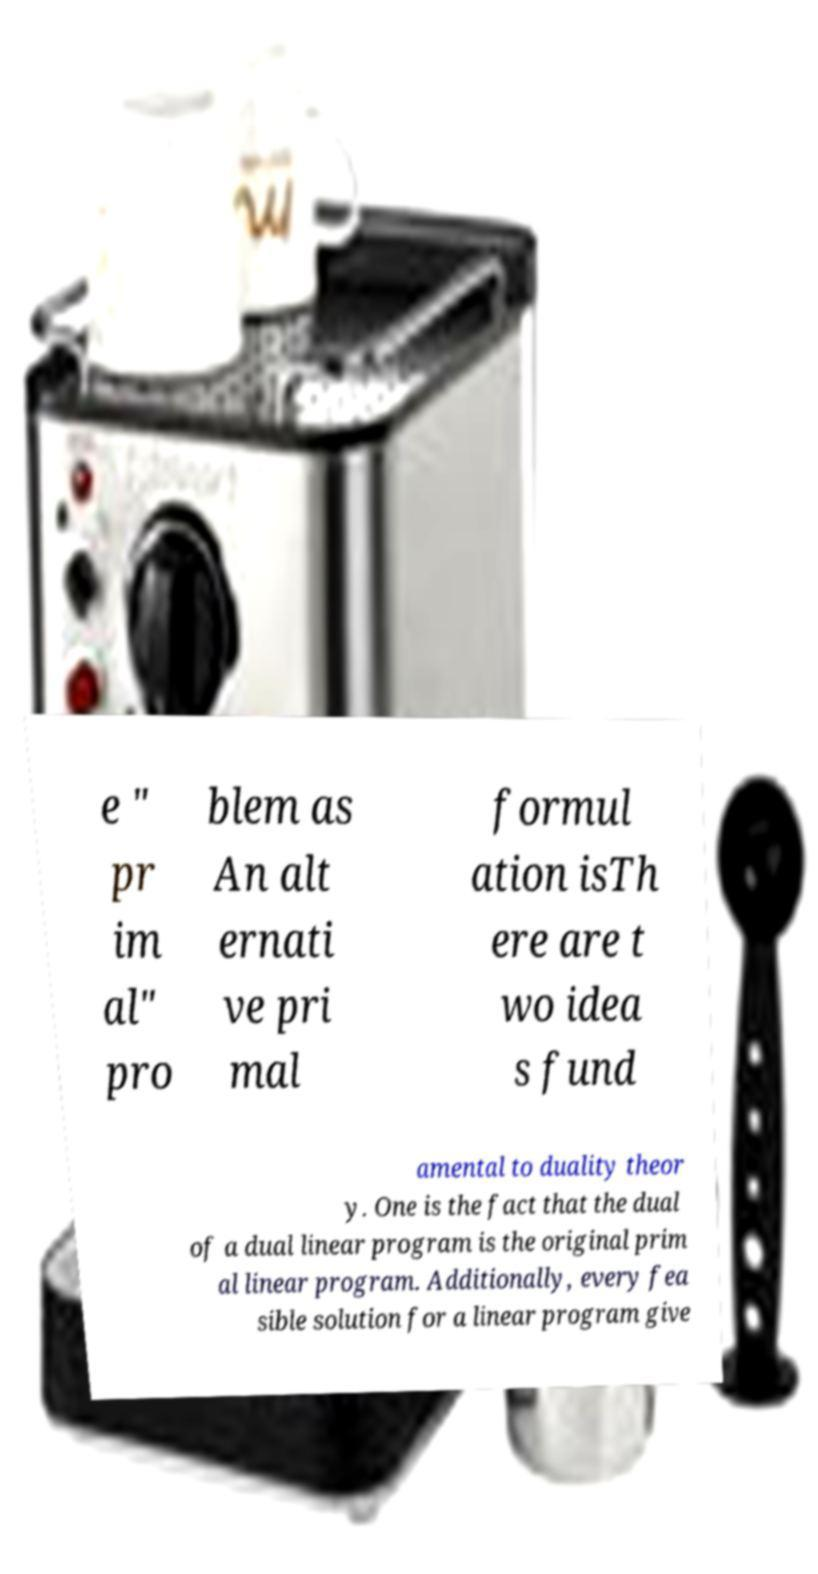Please read and relay the text visible in this image. What does it say? e " pr im al" pro blem as An alt ernati ve pri mal formul ation isTh ere are t wo idea s fund amental to duality theor y. One is the fact that the dual of a dual linear program is the original prim al linear program. Additionally, every fea sible solution for a linear program give 